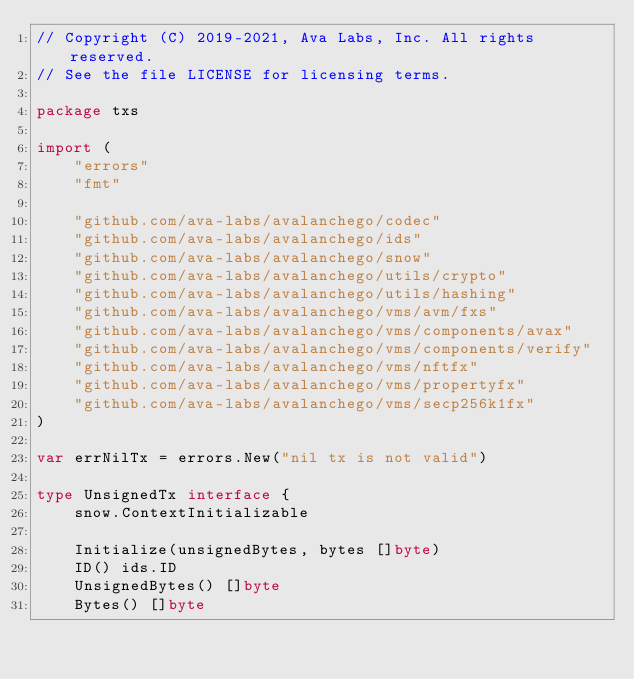Convert code to text. <code><loc_0><loc_0><loc_500><loc_500><_Go_>// Copyright (C) 2019-2021, Ava Labs, Inc. All rights reserved.
// See the file LICENSE for licensing terms.

package txs

import (
	"errors"
	"fmt"

	"github.com/ava-labs/avalanchego/codec"
	"github.com/ava-labs/avalanchego/ids"
	"github.com/ava-labs/avalanchego/snow"
	"github.com/ava-labs/avalanchego/utils/crypto"
	"github.com/ava-labs/avalanchego/utils/hashing"
	"github.com/ava-labs/avalanchego/vms/avm/fxs"
	"github.com/ava-labs/avalanchego/vms/components/avax"
	"github.com/ava-labs/avalanchego/vms/components/verify"
	"github.com/ava-labs/avalanchego/vms/nftfx"
	"github.com/ava-labs/avalanchego/vms/propertyfx"
	"github.com/ava-labs/avalanchego/vms/secp256k1fx"
)

var errNilTx = errors.New("nil tx is not valid")

type UnsignedTx interface {
	snow.ContextInitializable

	Initialize(unsignedBytes, bytes []byte)
	ID() ids.ID
	UnsignedBytes() []byte
	Bytes() []byte
</code> 